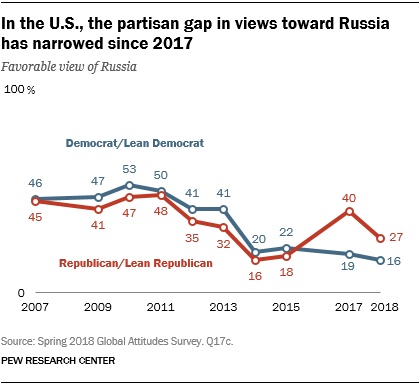Highlight a few significant elements in this photo. In 2017, the color of a graph with a value of 40 was red. The sum of all the values below 20 in the red graph is 34. 